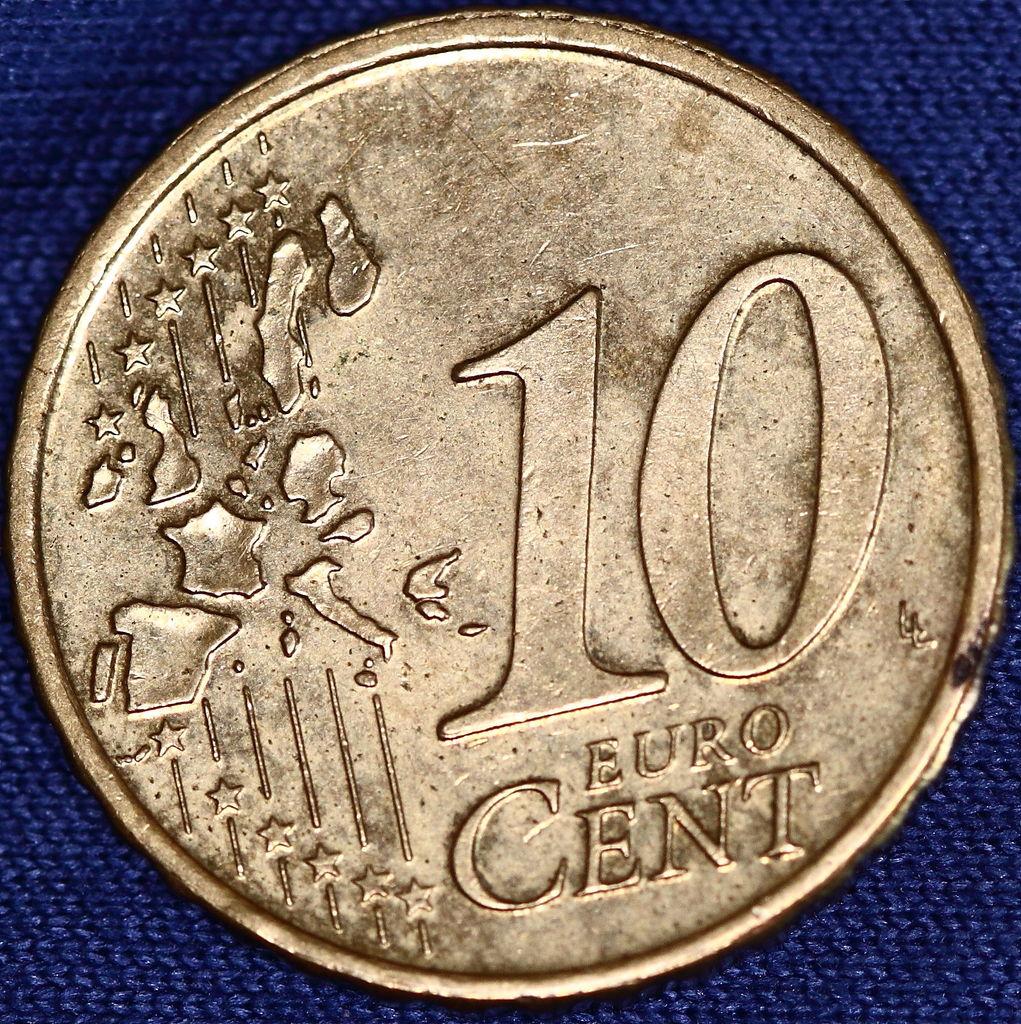How many euro cents is the coin worth?
Offer a very short reply. 10. 